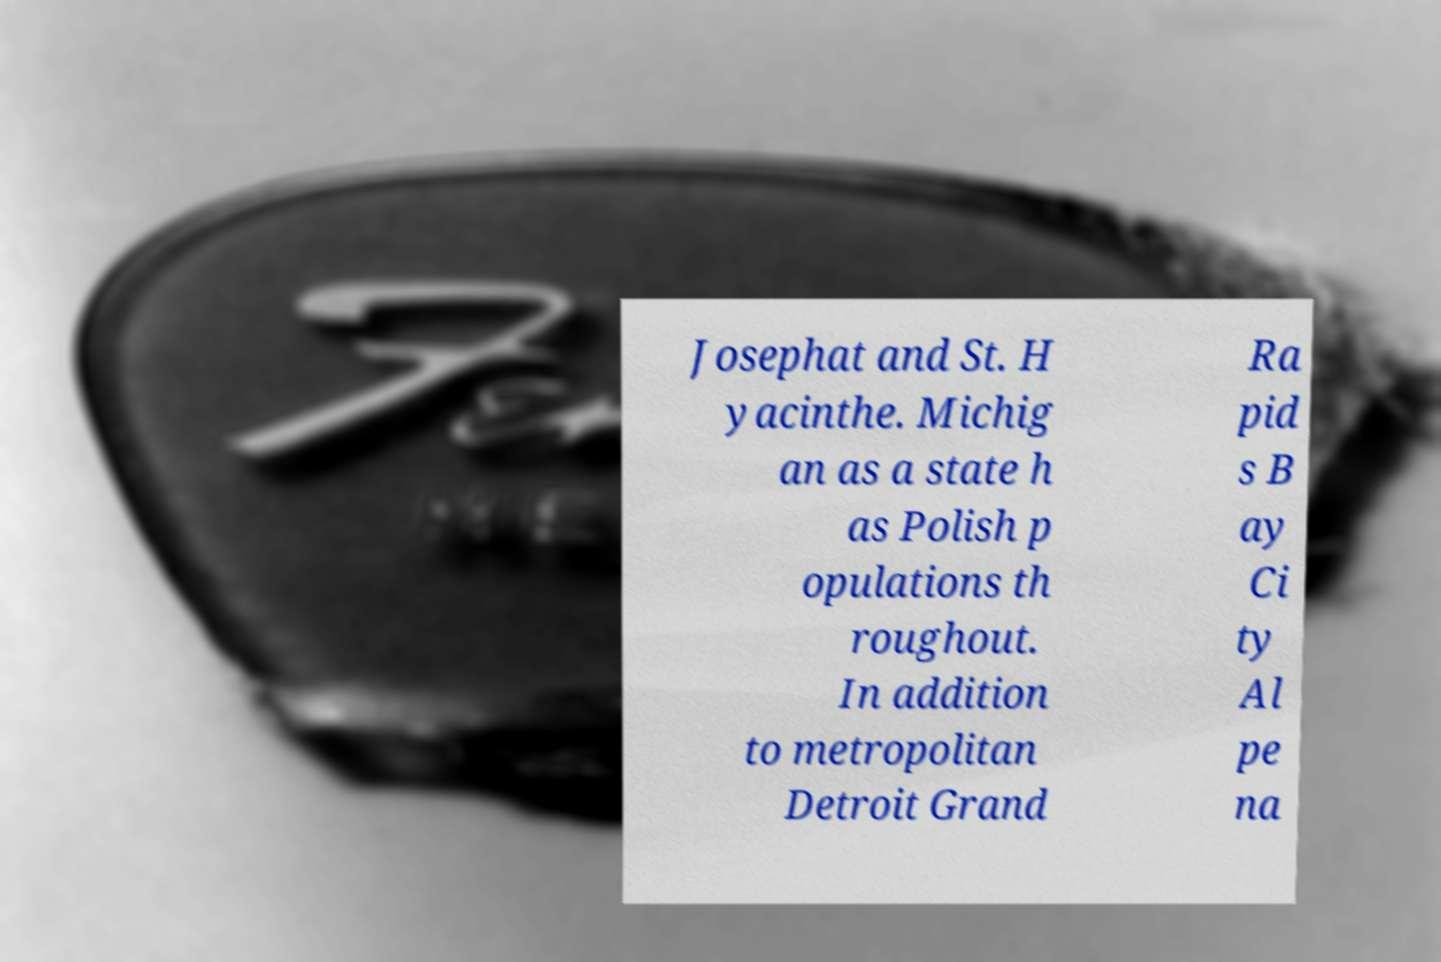I need the written content from this picture converted into text. Can you do that? Josephat and St. H yacinthe. Michig an as a state h as Polish p opulations th roughout. In addition to metropolitan Detroit Grand Ra pid s B ay Ci ty Al pe na 